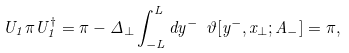Convert formula to latex. <formula><loc_0><loc_0><loc_500><loc_500>U _ { 1 } \pi U _ { 1 } ^ { \dagger } = \pi - \Delta _ { \perp } \int _ { - L } ^ { L } d y ^ { - } \ \vartheta [ y ^ { - } , x _ { \perp } ; A _ { - } ] = \pi ,</formula> 